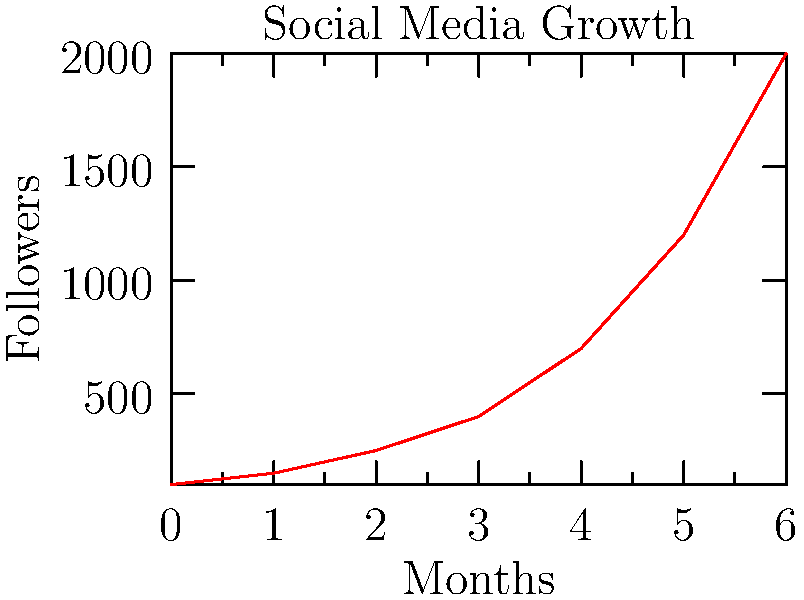The graph shows the growth of a social media influencer's followers over 6 months. If this trend continues, approximately how many followers can the influencer expect to have at the end of the 8th month? To solve this problem, we need to analyze the trend in the graph and make a reasonable prediction:

1. Observe that the growth is not linear, but exponential.
2. Calculate the growth rate between months 5 and 6:
   $\text{Growth rate} = \frac{2000 - 1200}{1200} \approx 0.67$ or 67%
3. Assume this growth rate continues for the next two months:
   Month 7: $2000 \times (1 + 0.67) \approx 3340$
   Month 8: $3340 \times (1 + 0.67) \approx 5578$
4. Round to the nearest hundred for a reasonable estimate.

This exponential growth is typical in social media, where increased visibility leads to even faster growth, a phenomenon often called "going viral".
Answer: Approximately 5,600 followers 